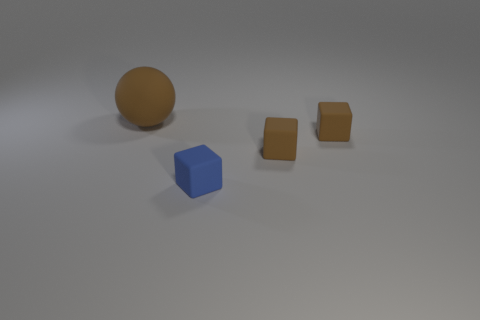Add 3 big brown cylinders. How many objects exist? 7 Subtract all spheres. How many objects are left? 3 Subtract 0 yellow blocks. How many objects are left? 4 Subtract all small green matte cylinders. Subtract all brown objects. How many objects are left? 1 Add 4 large spheres. How many large spheres are left? 5 Add 2 tiny blue objects. How many tiny blue objects exist? 3 